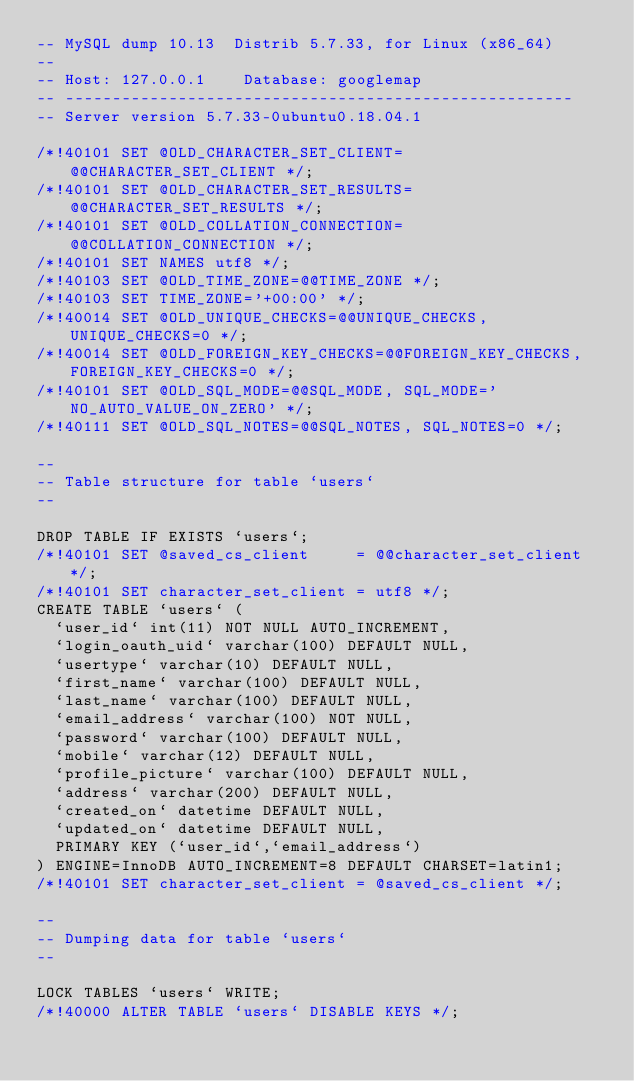Convert code to text. <code><loc_0><loc_0><loc_500><loc_500><_SQL_>-- MySQL dump 10.13  Distrib 5.7.33, for Linux (x86_64)
--
-- Host: 127.0.0.1    Database: googlemap
-- ------------------------------------------------------
-- Server version	5.7.33-0ubuntu0.18.04.1

/*!40101 SET @OLD_CHARACTER_SET_CLIENT=@@CHARACTER_SET_CLIENT */;
/*!40101 SET @OLD_CHARACTER_SET_RESULTS=@@CHARACTER_SET_RESULTS */;
/*!40101 SET @OLD_COLLATION_CONNECTION=@@COLLATION_CONNECTION */;
/*!40101 SET NAMES utf8 */;
/*!40103 SET @OLD_TIME_ZONE=@@TIME_ZONE */;
/*!40103 SET TIME_ZONE='+00:00' */;
/*!40014 SET @OLD_UNIQUE_CHECKS=@@UNIQUE_CHECKS, UNIQUE_CHECKS=0 */;
/*!40014 SET @OLD_FOREIGN_KEY_CHECKS=@@FOREIGN_KEY_CHECKS, FOREIGN_KEY_CHECKS=0 */;
/*!40101 SET @OLD_SQL_MODE=@@SQL_MODE, SQL_MODE='NO_AUTO_VALUE_ON_ZERO' */;
/*!40111 SET @OLD_SQL_NOTES=@@SQL_NOTES, SQL_NOTES=0 */;

--
-- Table structure for table `users`
--

DROP TABLE IF EXISTS `users`;
/*!40101 SET @saved_cs_client     = @@character_set_client */;
/*!40101 SET character_set_client = utf8 */;
CREATE TABLE `users` (
  `user_id` int(11) NOT NULL AUTO_INCREMENT,
  `login_oauth_uid` varchar(100) DEFAULT NULL,
  `usertype` varchar(10) DEFAULT NULL,
  `first_name` varchar(100) DEFAULT NULL,
  `last_name` varchar(100) DEFAULT NULL,
  `email_address` varchar(100) NOT NULL,
  `password` varchar(100) DEFAULT NULL,
  `mobile` varchar(12) DEFAULT NULL,
  `profile_picture` varchar(100) DEFAULT NULL,
  `address` varchar(200) DEFAULT NULL,
  `created_on` datetime DEFAULT NULL,
  `updated_on` datetime DEFAULT NULL,
  PRIMARY KEY (`user_id`,`email_address`)
) ENGINE=InnoDB AUTO_INCREMENT=8 DEFAULT CHARSET=latin1;
/*!40101 SET character_set_client = @saved_cs_client */;

--
-- Dumping data for table `users`
--

LOCK TABLES `users` WRITE;
/*!40000 ALTER TABLE `users` DISABLE KEYS */;</code> 